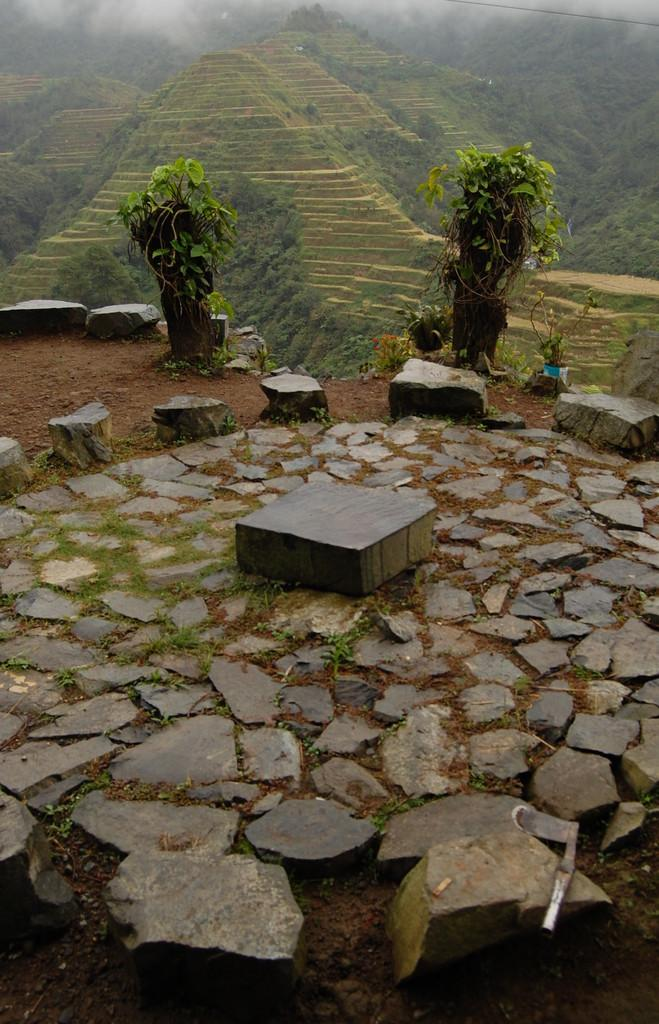What type of objects can be seen in the image? There are stones and plants in the image. Can you describe the landscape in the image? In the background of the image, there are hills visible. What type of soup is being served on the machine in the image? There is no machine or soup present in the image; it features stones and plants with hills in the background. 